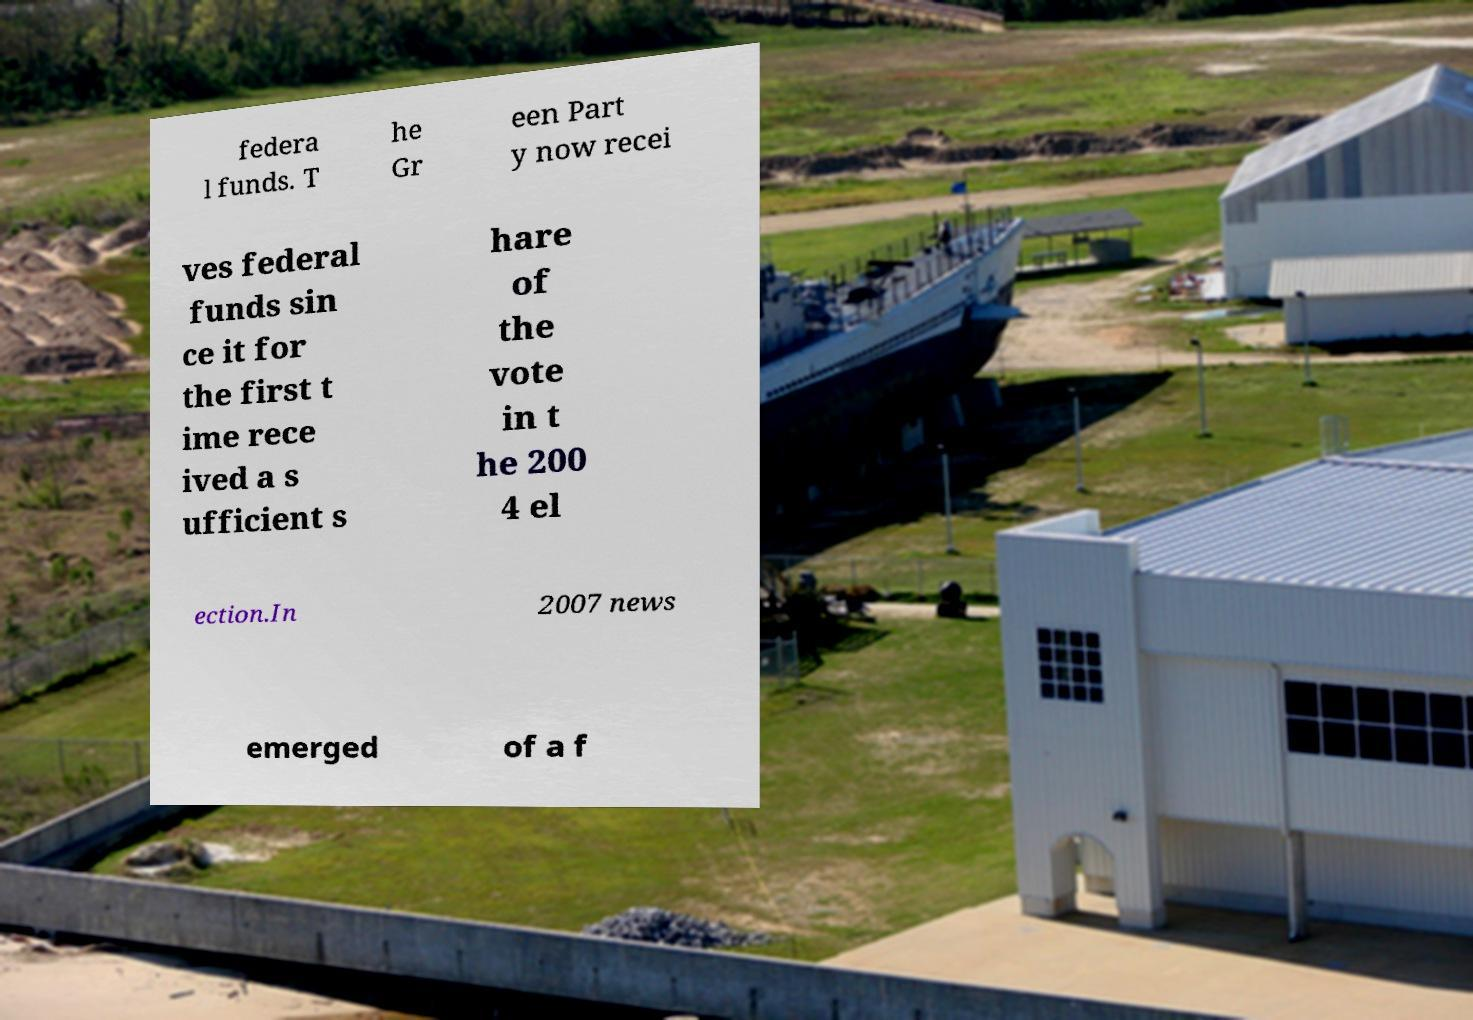Could you extract and type out the text from this image? federa l funds. T he Gr een Part y now recei ves federal funds sin ce it for the first t ime rece ived a s ufficient s hare of the vote in t he 200 4 el ection.In 2007 news emerged of a f 